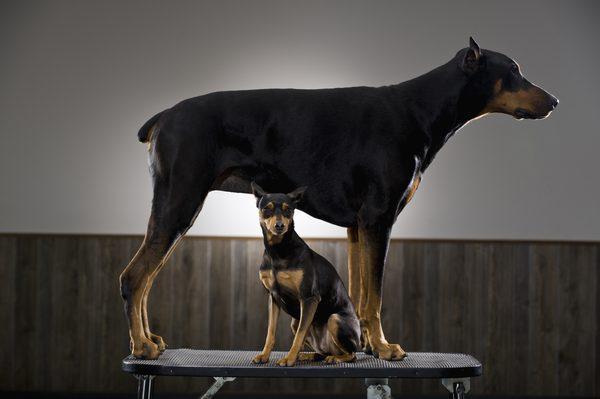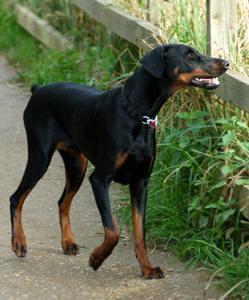The first image is the image on the left, the second image is the image on the right. For the images displayed, is the sentence "The dog in the image on the left is situated in the grass." factually correct? Answer yes or no. No. 